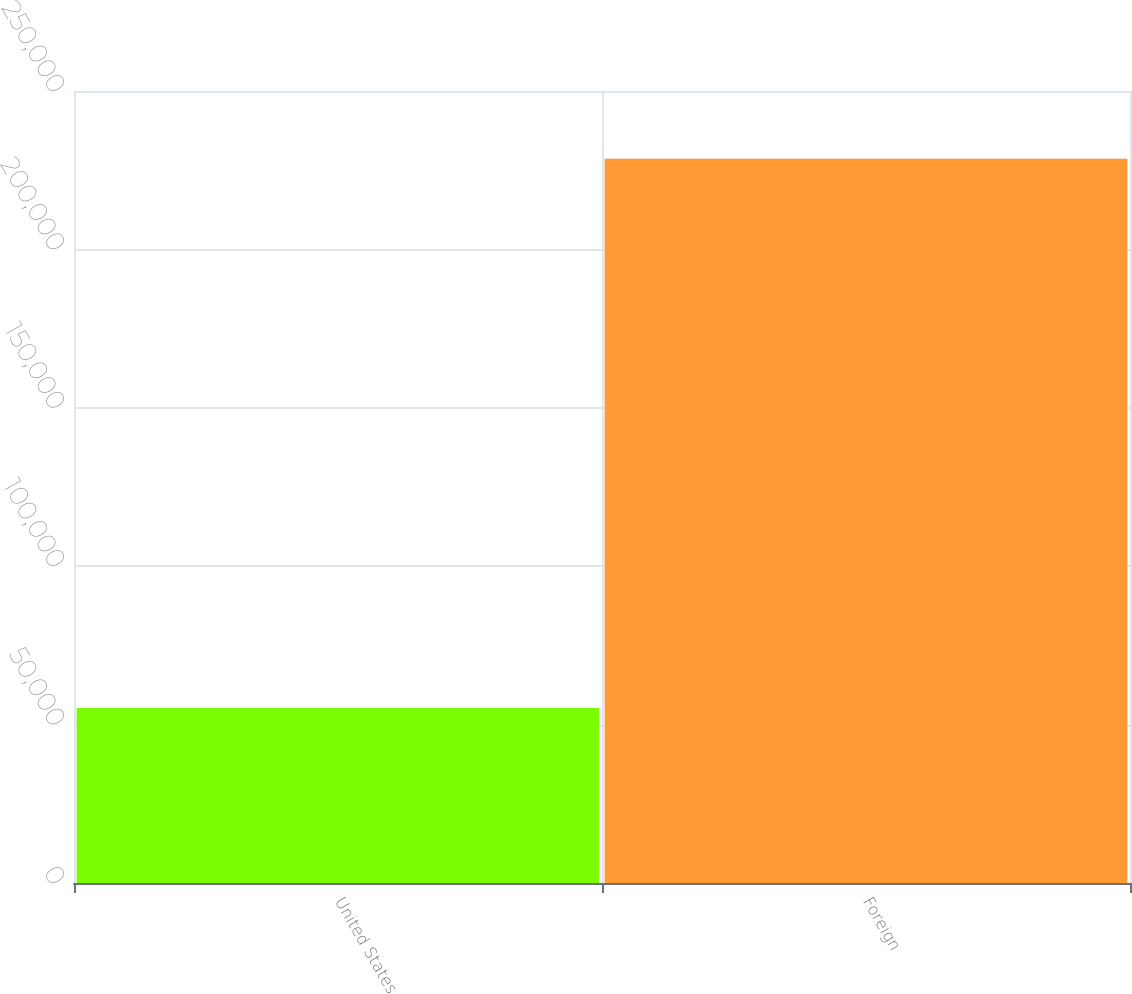Convert chart to OTSL. <chart><loc_0><loc_0><loc_500><loc_500><bar_chart><fcel>United States<fcel>Foreign<nl><fcel>55279<fcel>228623<nl></chart> 